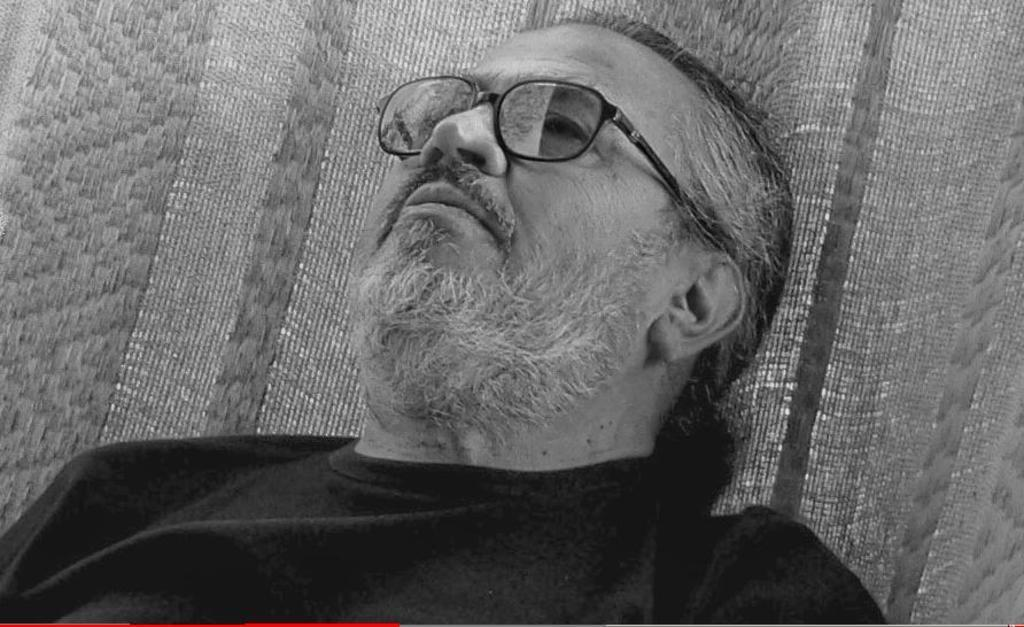Who is in the picture? There is a man in the picture. What is the man wearing? The man is wearing a black T-shirt. What is the man doing in the picture? The man is sleeping. What is visible behind the man? There is a cloth or a net visible behind the man. What is the color scheme of the picture? The picture is in black and white. What type of leg is visible in the picture? There is no leg visible in the picture; it is a man sleeping, and only his upper body is shown. 